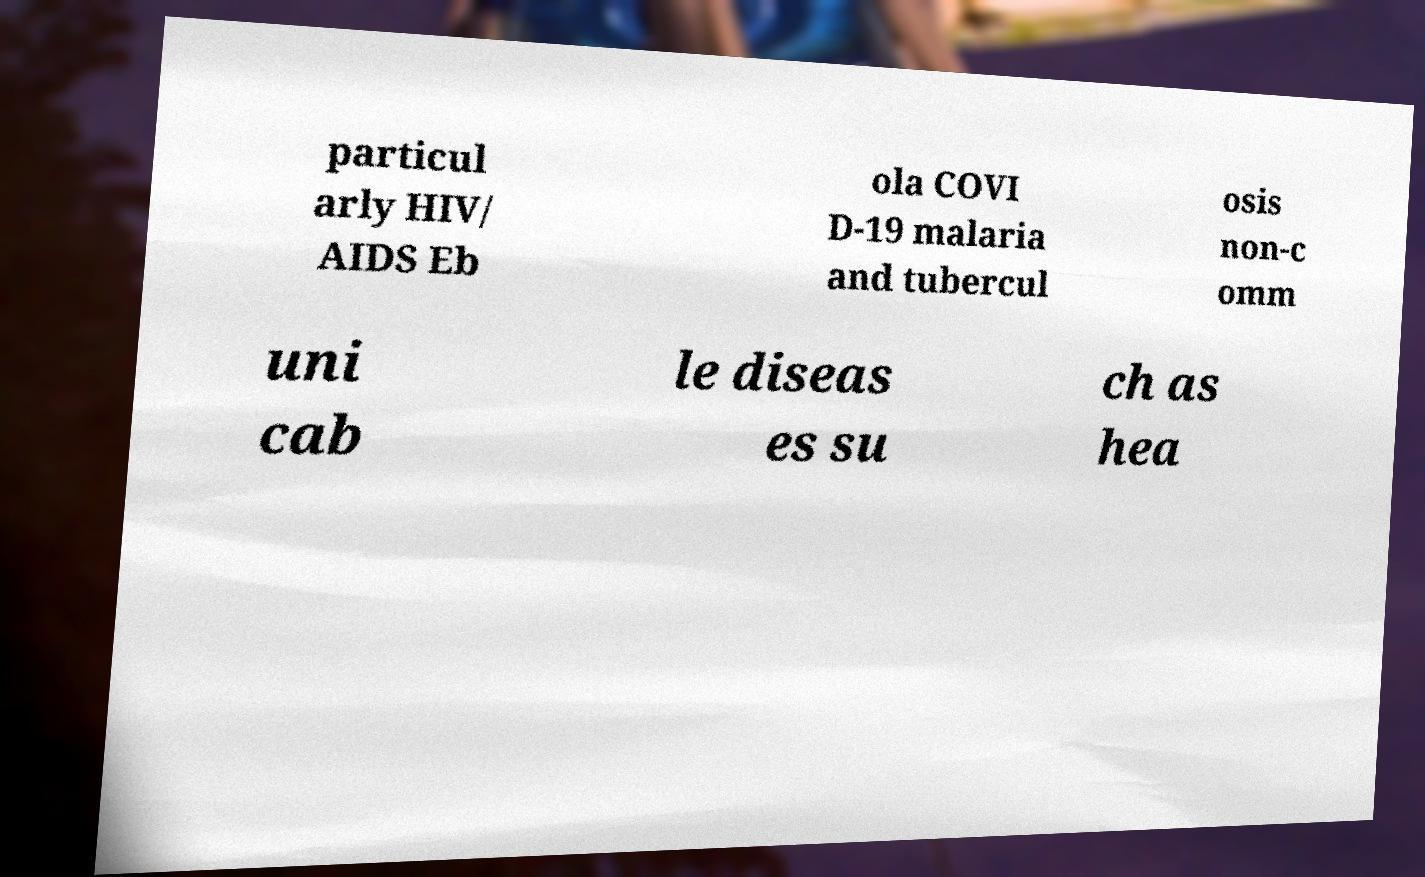For documentation purposes, I need the text within this image transcribed. Could you provide that? particul arly HIV/ AIDS Eb ola COVI D-19 malaria and tubercul osis non-c omm uni cab le diseas es su ch as hea 